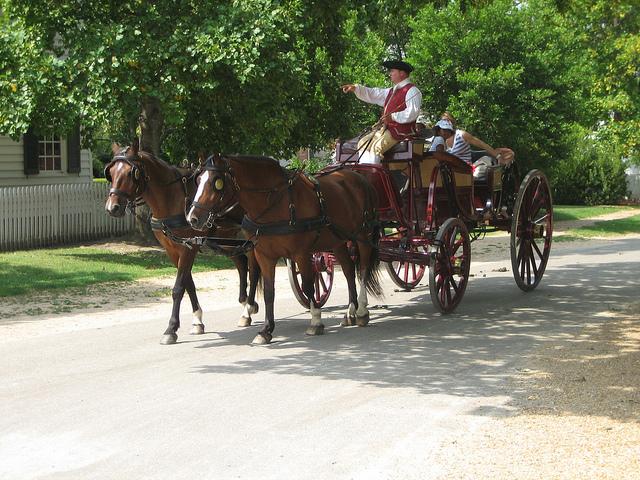How many horses are pulling the carriage?
Write a very short answer. 2. What time period is he dressed from?
Be succinct. Colonial. Does the guy have a hat on?
Keep it brief. Yes. 